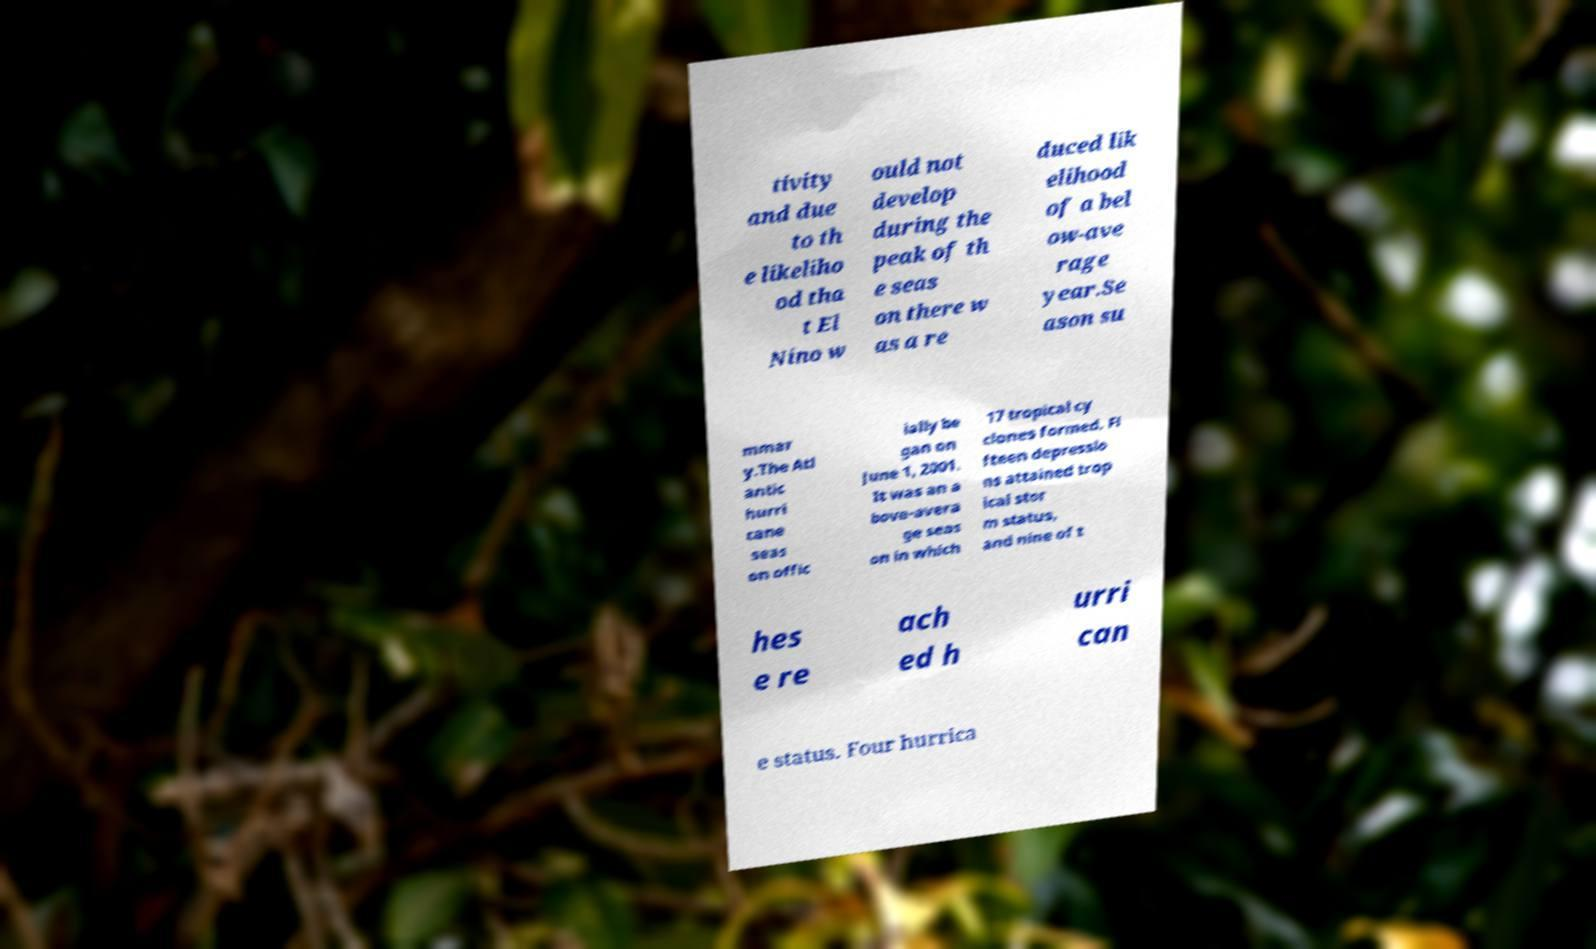There's text embedded in this image that I need extracted. Can you transcribe it verbatim? tivity and due to th e likeliho od tha t El Nino w ould not develop during the peak of th e seas on there w as a re duced lik elihood of a bel ow-ave rage year.Se ason su mmar y.The Atl antic hurri cane seas on offic ially be gan on June 1, 2001. It was an a bove-avera ge seas on in which 17 tropical cy clones formed. Fi fteen depressio ns attained trop ical stor m status, and nine of t hes e re ach ed h urri can e status. Four hurrica 